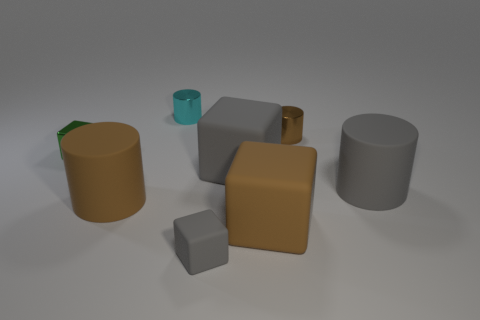There is a small cyan shiny object; are there any matte blocks behind it? Indeed, there are no matte blocks positioned directly behind the small cyan shiny object. The scene consists of several geometric shapes, each with a distinctive finish, and they are all placed against what appears to be a neutral background. 